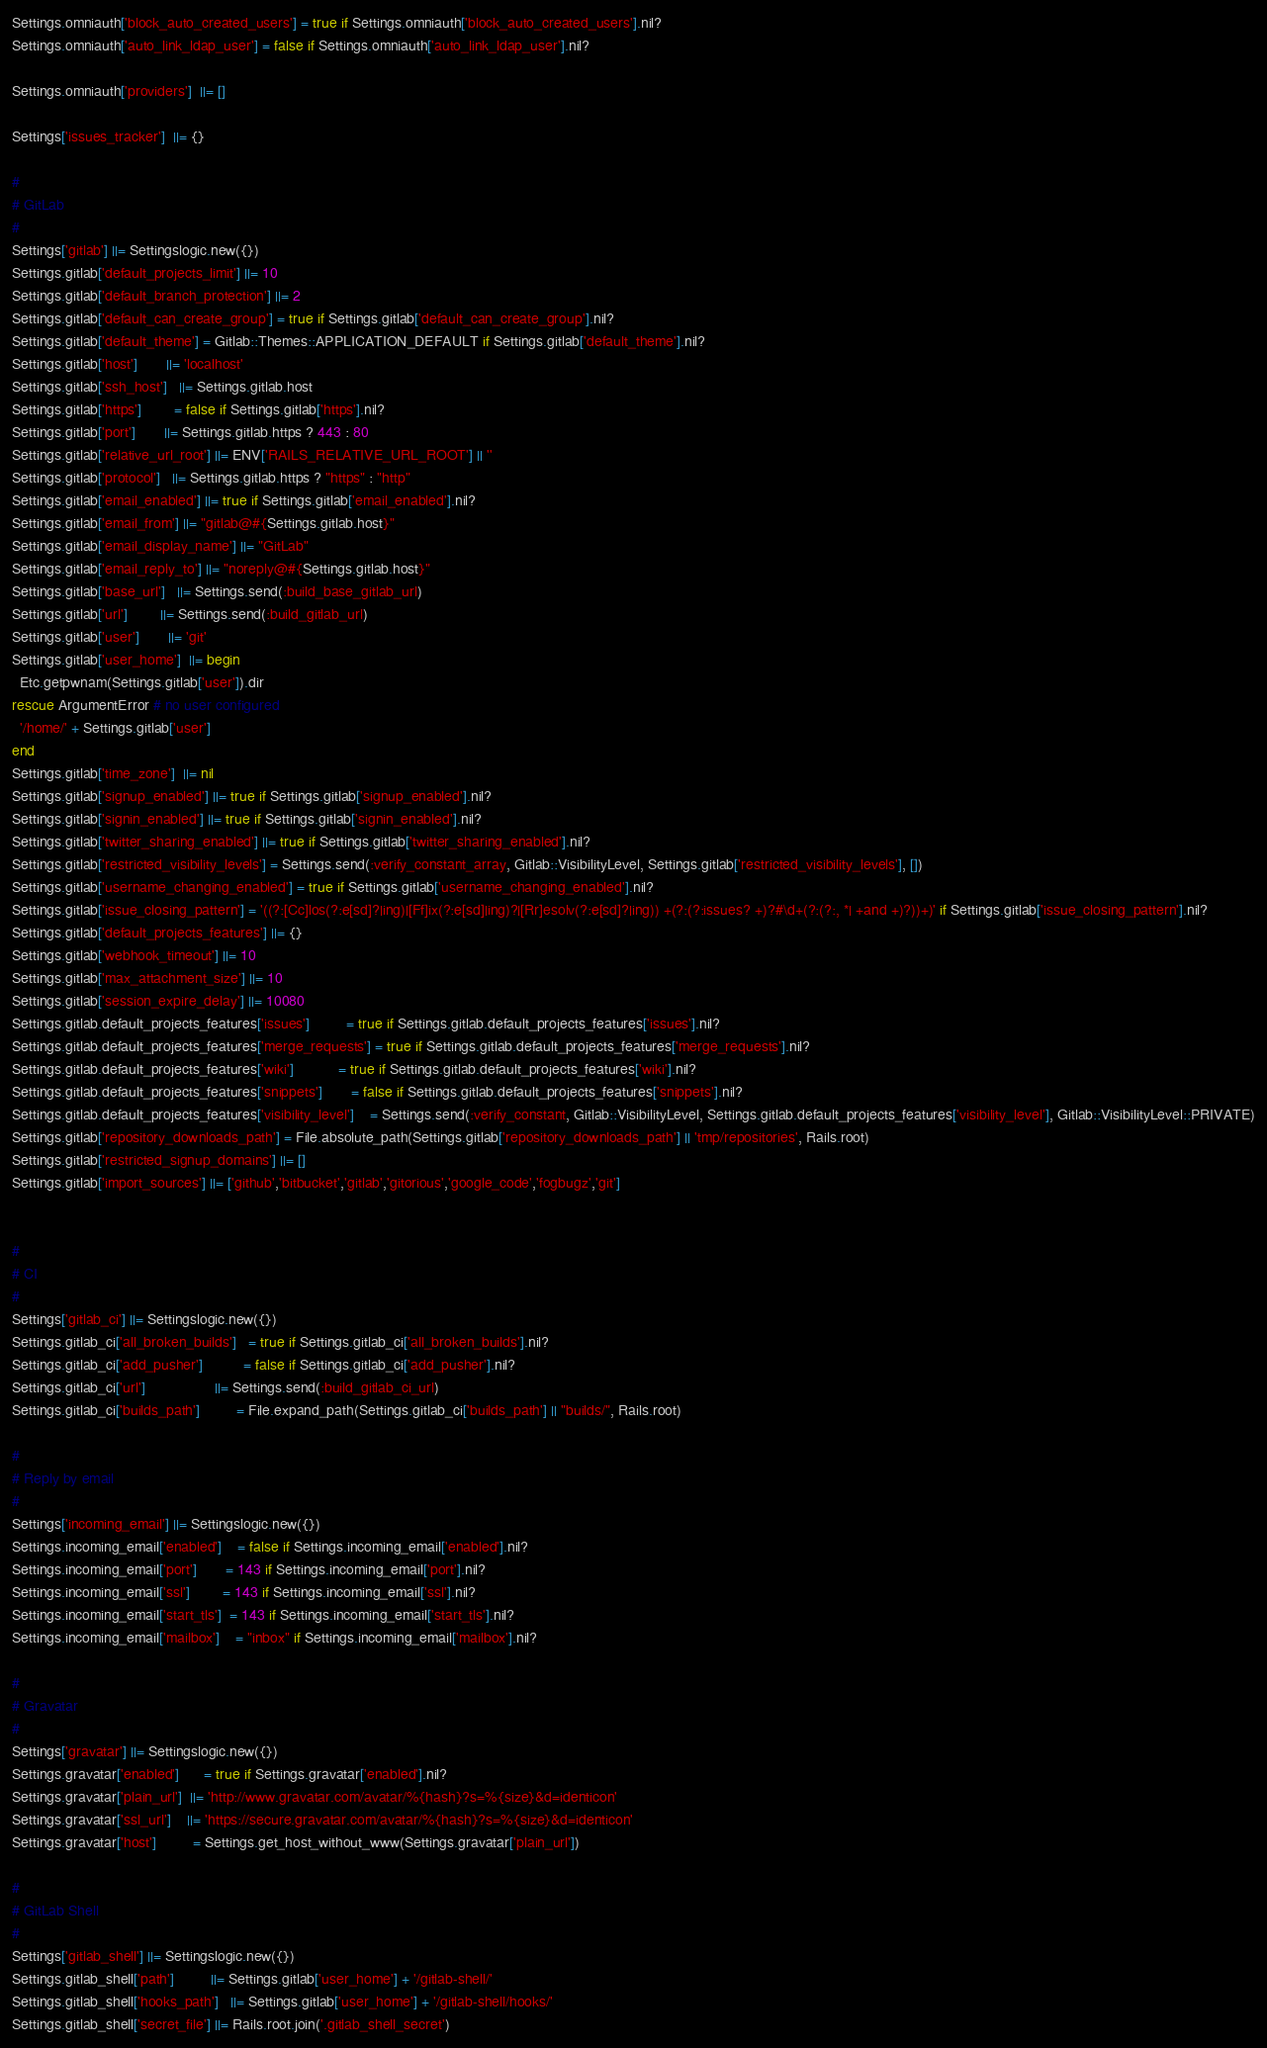Convert code to text. <code><loc_0><loc_0><loc_500><loc_500><_Ruby_>Settings.omniauth['block_auto_created_users'] = true if Settings.omniauth['block_auto_created_users'].nil?
Settings.omniauth['auto_link_ldap_user'] = false if Settings.omniauth['auto_link_ldap_user'].nil?

Settings.omniauth['providers']  ||= []

Settings['issues_tracker']  ||= {}

#
# GitLab
#
Settings['gitlab'] ||= Settingslogic.new({})
Settings.gitlab['default_projects_limit'] ||= 10
Settings.gitlab['default_branch_protection'] ||= 2
Settings.gitlab['default_can_create_group'] = true if Settings.gitlab['default_can_create_group'].nil?
Settings.gitlab['default_theme'] = Gitlab::Themes::APPLICATION_DEFAULT if Settings.gitlab['default_theme'].nil?
Settings.gitlab['host']       ||= 'localhost'
Settings.gitlab['ssh_host']   ||= Settings.gitlab.host
Settings.gitlab['https']        = false if Settings.gitlab['https'].nil?
Settings.gitlab['port']       ||= Settings.gitlab.https ? 443 : 80
Settings.gitlab['relative_url_root'] ||= ENV['RAILS_RELATIVE_URL_ROOT'] || ''
Settings.gitlab['protocol']   ||= Settings.gitlab.https ? "https" : "http"
Settings.gitlab['email_enabled'] ||= true if Settings.gitlab['email_enabled'].nil?
Settings.gitlab['email_from'] ||= "gitlab@#{Settings.gitlab.host}"
Settings.gitlab['email_display_name'] ||= "GitLab"
Settings.gitlab['email_reply_to'] ||= "noreply@#{Settings.gitlab.host}"
Settings.gitlab['base_url']   ||= Settings.send(:build_base_gitlab_url)
Settings.gitlab['url']        ||= Settings.send(:build_gitlab_url)
Settings.gitlab['user']       ||= 'git'
Settings.gitlab['user_home']  ||= begin
  Etc.getpwnam(Settings.gitlab['user']).dir
rescue ArgumentError # no user configured
  '/home/' + Settings.gitlab['user']
end
Settings.gitlab['time_zone']  ||= nil
Settings.gitlab['signup_enabled'] ||= true if Settings.gitlab['signup_enabled'].nil?
Settings.gitlab['signin_enabled'] ||= true if Settings.gitlab['signin_enabled'].nil?
Settings.gitlab['twitter_sharing_enabled'] ||= true if Settings.gitlab['twitter_sharing_enabled'].nil?
Settings.gitlab['restricted_visibility_levels'] = Settings.send(:verify_constant_array, Gitlab::VisibilityLevel, Settings.gitlab['restricted_visibility_levels'], [])
Settings.gitlab['username_changing_enabled'] = true if Settings.gitlab['username_changing_enabled'].nil?
Settings.gitlab['issue_closing_pattern'] = '((?:[Cc]los(?:e[sd]?|ing)|[Ff]ix(?:e[sd]|ing)?|[Rr]esolv(?:e[sd]?|ing)) +(?:(?:issues? +)?#\d+(?:(?:, *| +and +)?))+)' if Settings.gitlab['issue_closing_pattern'].nil?
Settings.gitlab['default_projects_features'] ||= {}
Settings.gitlab['webhook_timeout'] ||= 10
Settings.gitlab['max_attachment_size'] ||= 10
Settings.gitlab['session_expire_delay'] ||= 10080
Settings.gitlab.default_projects_features['issues']         = true if Settings.gitlab.default_projects_features['issues'].nil?
Settings.gitlab.default_projects_features['merge_requests'] = true if Settings.gitlab.default_projects_features['merge_requests'].nil?
Settings.gitlab.default_projects_features['wiki']           = true if Settings.gitlab.default_projects_features['wiki'].nil?
Settings.gitlab.default_projects_features['snippets']       = false if Settings.gitlab.default_projects_features['snippets'].nil?
Settings.gitlab.default_projects_features['visibility_level']    = Settings.send(:verify_constant, Gitlab::VisibilityLevel, Settings.gitlab.default_projects_features['visibility_level'], Gitlab::VisibilityLevel::PRIVATE)
Settings.gitlab['repository_downloads_path'] = File.absolute_path(Settings.gitlab['repository_downloads_path'] || 'tmp/repositories', Rails.root)
Settings.gitlab['restricted_signup_domains'] ||= []
Settings.gitlab['import_sources'] ||= ['github','bitbucket','gitlab','gitorious','google_code','fogbugz','git']


#
# CI
#
Settings['gitlab_ci'] ||= Settingslogic.new({})
Settings.gitlab_ci['all_broken_builds']   = true if Settings.gitlab_ci['all_broken_builds'].nil?
Settings.gitlab_ci['add_pusher']          = false if Settings.gitlab_ci['add_pusher'].nil?
Settings.gitlab_ci['url']                 ||= Settings.send(:build_gitlab_ci_url)
Settings.gitlab_ci['builds_path']         = File.expand_path(Settings.gitlab_ci['builds_path'] || "builds/", Rails.root)

#
# Reply by email
#
Settings['incoming_email'] ||= Settingslogic.new({})
Settings.incoming_email['enabled']    = false if Settings.incoming_email['enabled'].nil?
Settings.incoming_email['port']       = 143 if Settings.incoming_email['port'].nil?
Settings.incoming_email['ssl']        = 143 if Settings.incoming_email['ssl'].nil?
Settings.incoming_email['start_tls']  = 143 if Settings.incoming_email['start_tls'].nil?
Settings.incoming_email['mailbox']    = "inbox" if Settings.incoming_email['mailbox'].nil?

#
# Gravatar
#
Settings['gravatar'] ||= Settingslogic.new({})
Settings.gravatar['enabled']      = true if Settings.gravatar['enabled'].nil?
Settings.gravatar['plain_url']  ||= 'http://www.gravatar.com/avatar/%{hash}?s=%{size}&d=identicon'
Settings.gravatar['ssl_url']    ||= 'https://secure.gravatar.com/avatar/%{hash}?s=%{size}&d=identicon'
Settings.gravatar['host']         = Settings.get_host_without_www(Settings.gravatar['plain_url'])

#
# GitLab Shell
#
Settings['gitlab_shell'] ||= Settingslogic.new({})
Settings.gitlab_shell['path']         ||= Settings.gitlab['user_home'] + '/gitlab-shell/'
Settings.gitlab_shell['hooks_path']   ||= Settings.gitlab['user_home'] + '/gitlab-shell/hooks/'
Settings.gitlab_shell['secret_file'] ||= Rails.root.join('.gitlab_shell_secret')</code> 